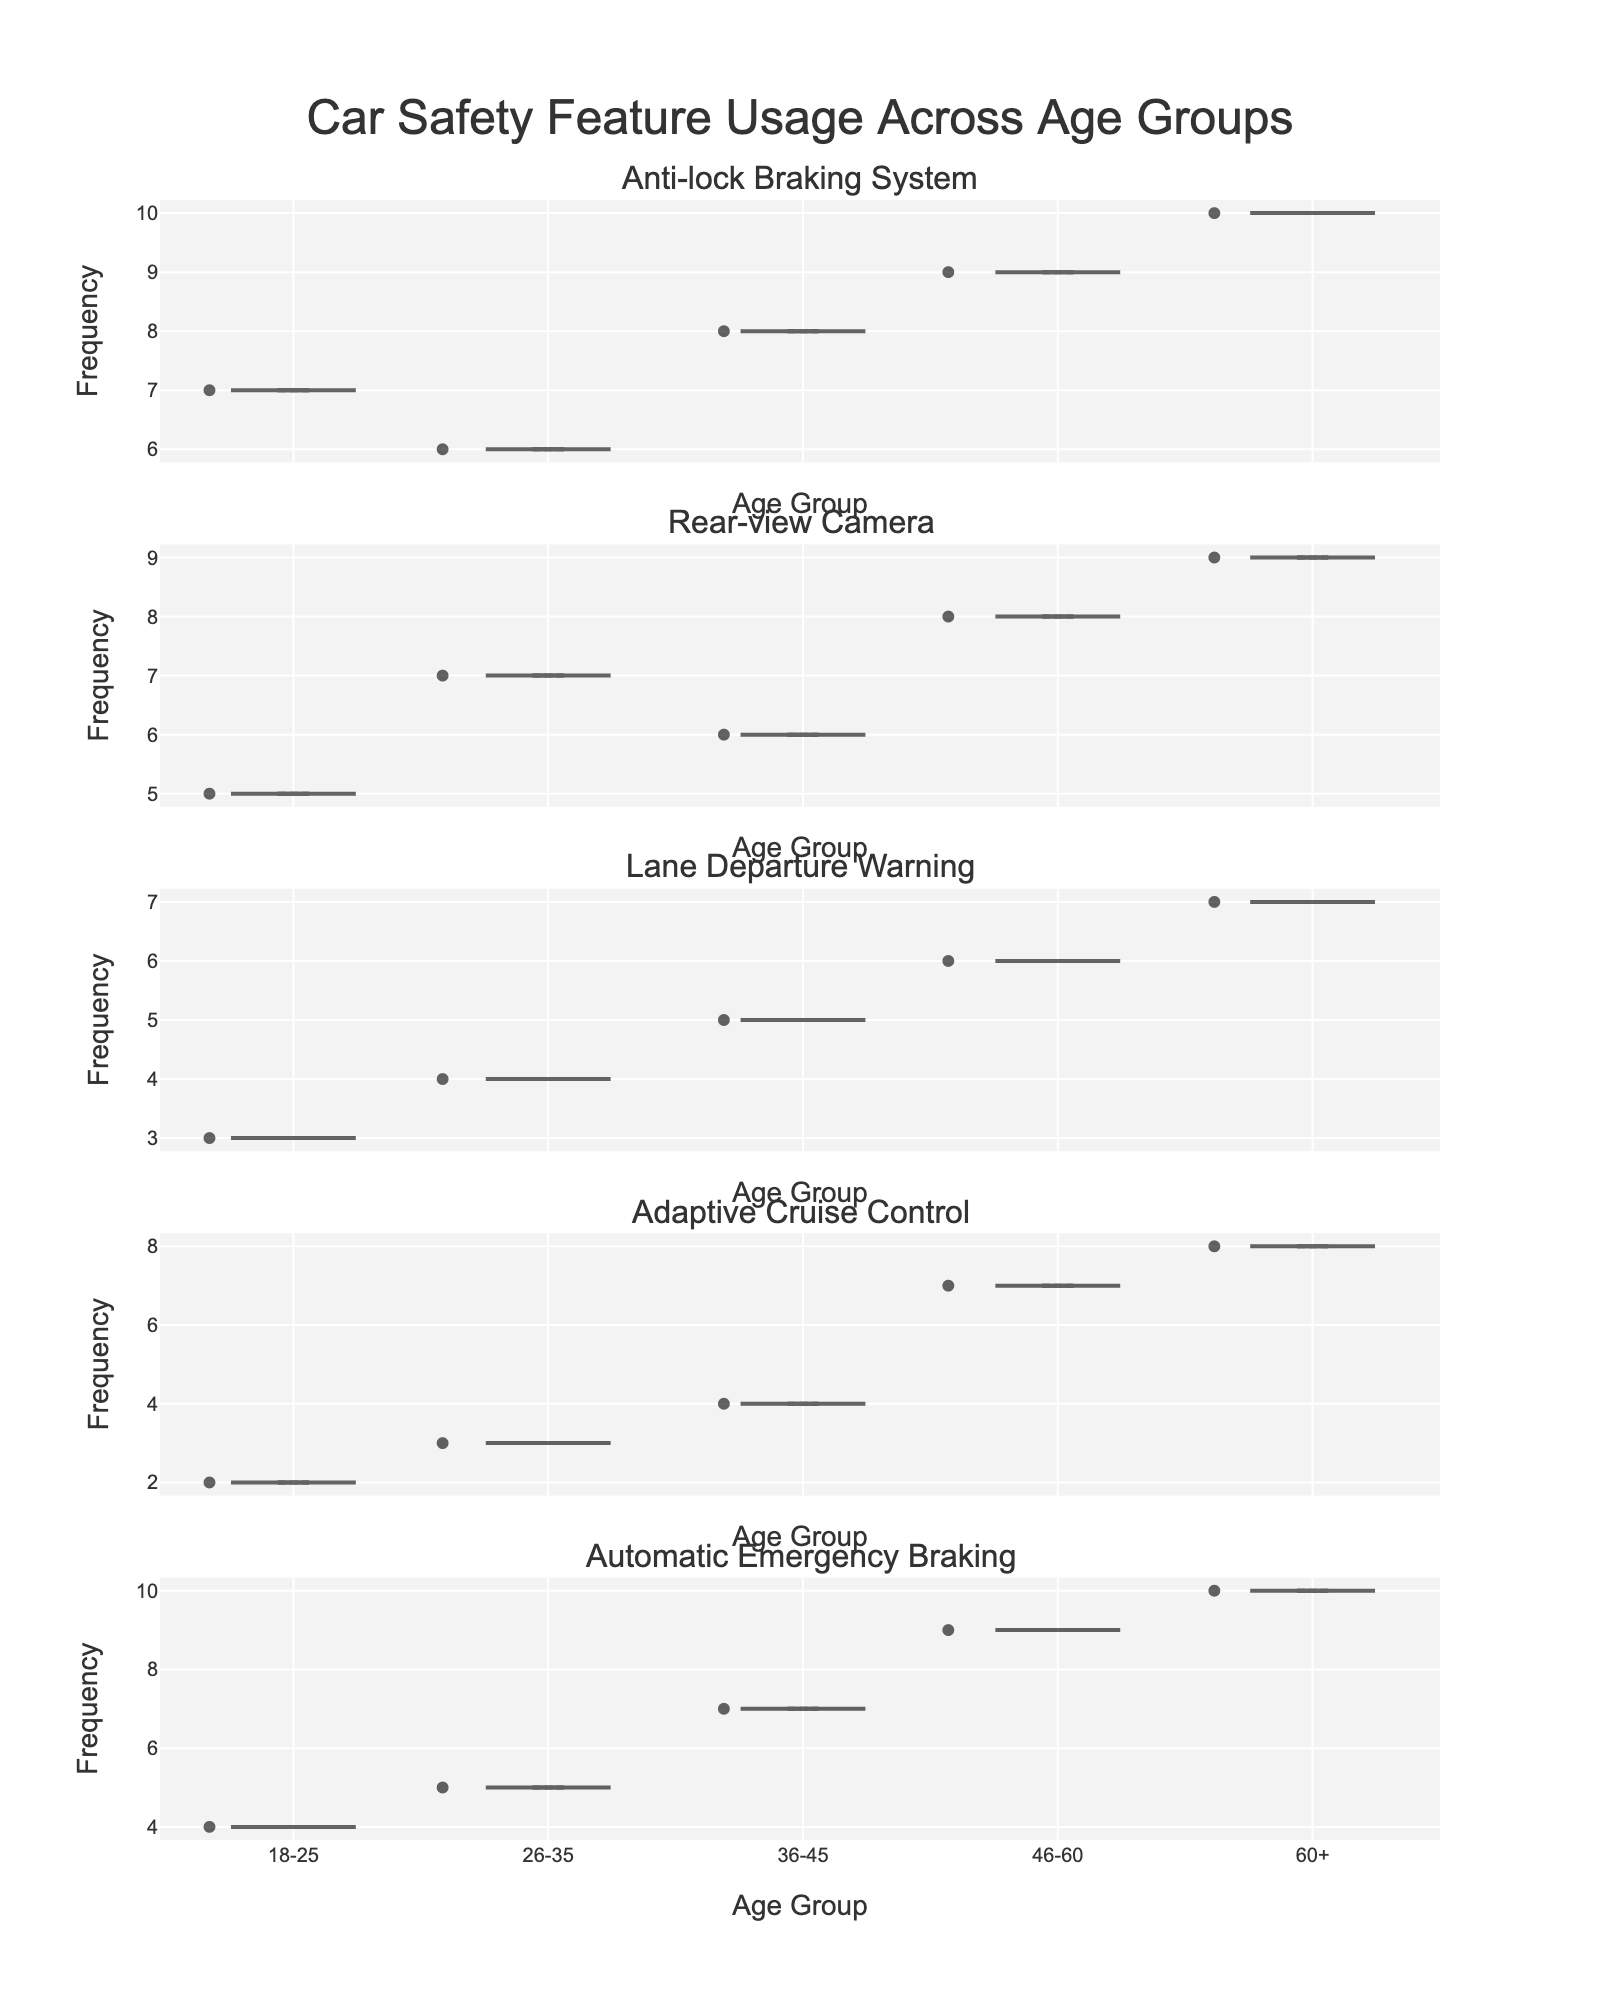What is the title of the figure? The title of the figure is usually displayed at the top of the plot. In this case, it reads "Car Safety Feature Usage Across Age Groups".
Answer: "Car Safety Feature Usage Across Age Groups" How many features are shown in the figure? By looking at the subplot titles, you can count the number of different car safety features. There are five subplot titles, so there are five features shown.
Answer: 5 Which age group uses the Anti-lock Braking System the most frequently? Identify the subplot for the Anti-lock Braking System and look for the age group with the highest value in that subplot's distribution. The age group 60+ has the highest frequency.
Answer: 60+ Which car safety feature has the highest average usage frequency among the 46-60 age group? Identify all subplots, then focus on the data points for the 46-60 age group in each subplot. Compare their average values visually. Automatic Emergency Braking has the highest average usage.
Answer: Automatic Emergency Braking What is the frequency of Lane Departure Warning usage in the 36-45 age group? Locate the subplot for Lane Departure Warning and identify the data point that corresponds to the 36-45 age group.
Answer: 5 Does the frequency of Adaptive Cruise Control usage increase or decrease with age? Examine the trend of the frequency values for Adaptive Cruise Control across all age groups. The trend shows that the frequency increases with age.
Answer: Increases Which safety feature shows the smallest change in usage frequency across different age groups? Compare the differences in frequency values for each feature across the age groups. The Rear-view Camera has more consistent frequency values.
Answer: Rear-view Camera What is the average frequency of usage for Automatic Emergency Braking across all age groups? Calculate the average of frequency values for Automatic Emergency Braking by summing them up (4 + 5 + 7 + 9 + 10) and dividing by 5 age groups. The sum is 35, so the average is 35/5.
Answer: 7 